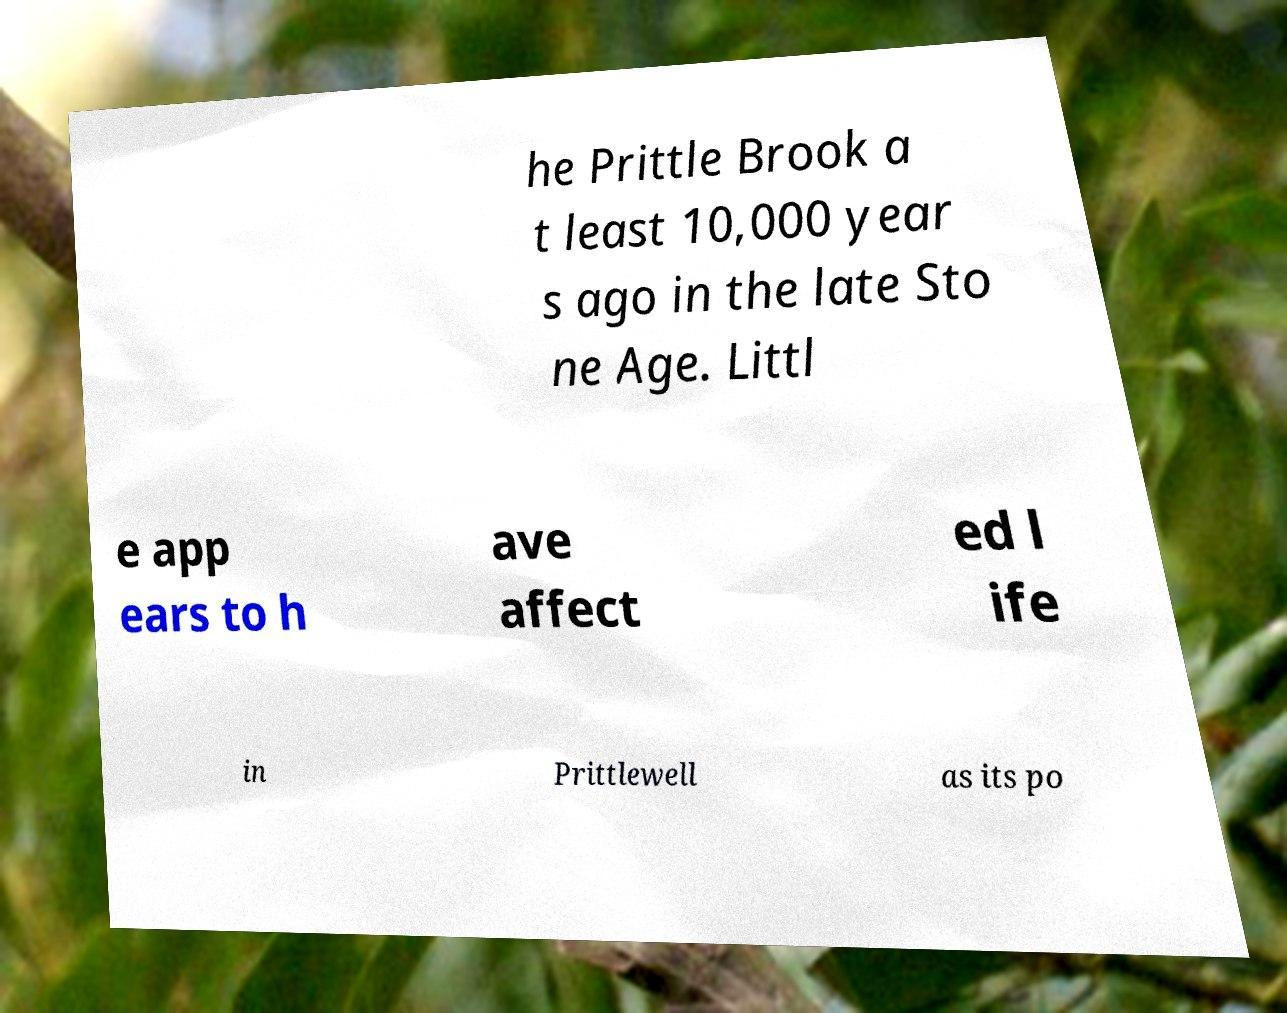There's text embedded in this image that I need extracted. Can you transcribe it verbatim? he Prittle Brook a t least 10,000 year s ago in the late Sto ne Age. Littl e app ears to h ave affect ed l ife in Prittlewell as its po 